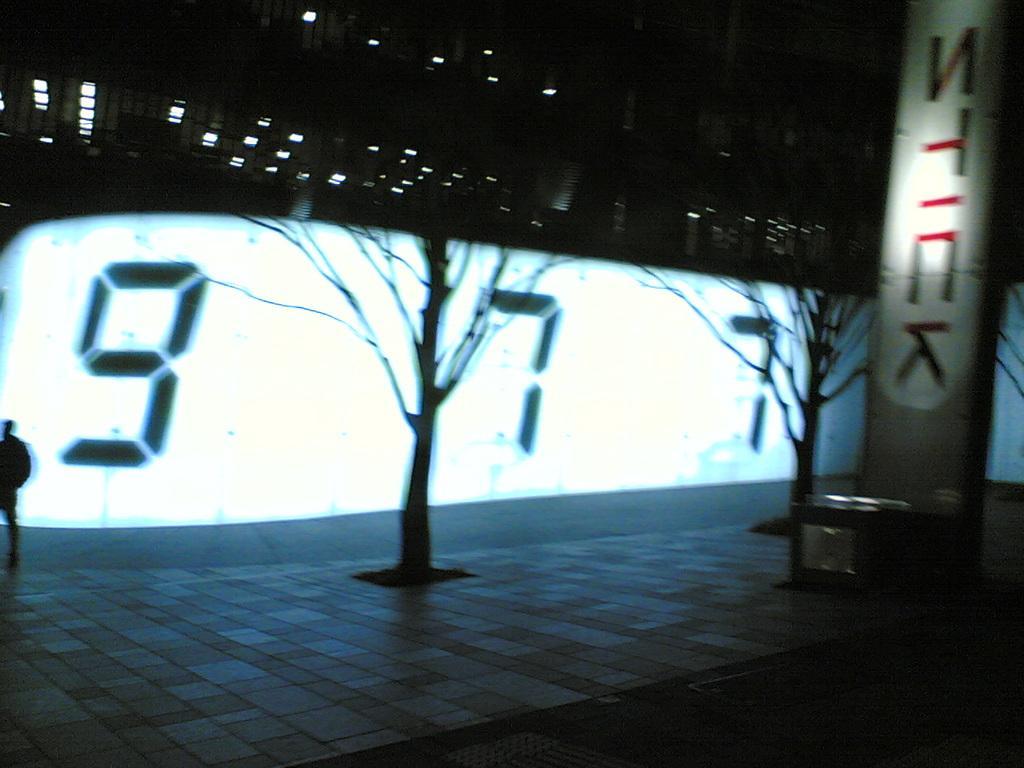Please provide a concise description of this image. In this image, we can see dry trees. There is a screen in the middle of the image. There is a board on the right side of the image. 